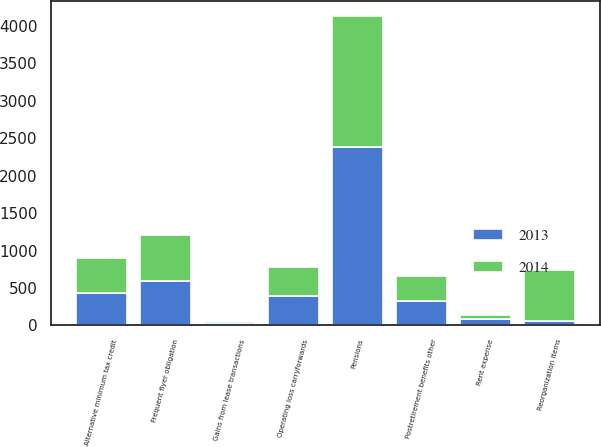Convert chart to OTSL. <chart><loc_0><loc_0><loc_500><loc_500><stacked_bar_chart><ecel><fcel>Postretirement benefits other<fcel>Rent expense<fcel>Alternative minimum tax credit<fcel>Operating loss carryforwards<fcel>Pensions<fcel>Frequent flyer obligation<fcel>Gains from lease transactions<fcel>Reorganization items<nl><fcel>2013<fcel>322<fcel>86<fcel>438<fcel>390<fcel>2385<fcel>589<fcel>22<fcel>64<nl><fcel>2014<fcel>342<fcel>55<fcel>467<fcel>390<fcel>1747<fcel>620<fcel>24<fcel>675<nl></chart> 